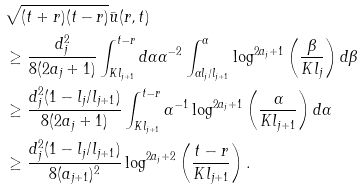Convert formula to latex. <formula><loc_0><loc_0><loc_500><loc_500>& \sqrt { ( t + r ) ( t - r ) } \bar { u } ( r , t ) \\ & \geq \frac { d _ { j } ^ { 2 } } { 8 ( 2 a _ { j } + 1 ) } \int _ { K l _ { j + 1 } } ^ { t - r } d \alpha \alpha ^ { - 2 } \int _ { \alpha l _ { j } / l _ { j + 1 } } ^ { \alpha } \log ^ { 2 a _ { j } + 1 } \left ( \frac { \beta } { K l _ { j } } \right ) d \beta \\ & \geq \frac { d _ { j } ^ { 2 } ( 1 - l _ { j } / l _ { j + 1 } ) } { 8 ( 2 a _ { j } + 1 ) } \int _ { K l _ { j + 1 } } ^ { t - r } \alpha ^ { - 1 } \log ^ { 2 a _ { j } + 1 } \left ( \frac { \alpha } { K l _ { j + 1 } } \right ) d \alpha \\ & \geq \frac { d _ { j } ^ { 2 } ( 1 - l _ { j } / l _ { j + 1 } ) } { 8 ( a _ { j + 1 } ) ^ { 2 } } \log ^ { 2 a _ { j } + 2 } \left ( \frac { t - r } { K l _ { j + 1 } } \right ) .</formula> 